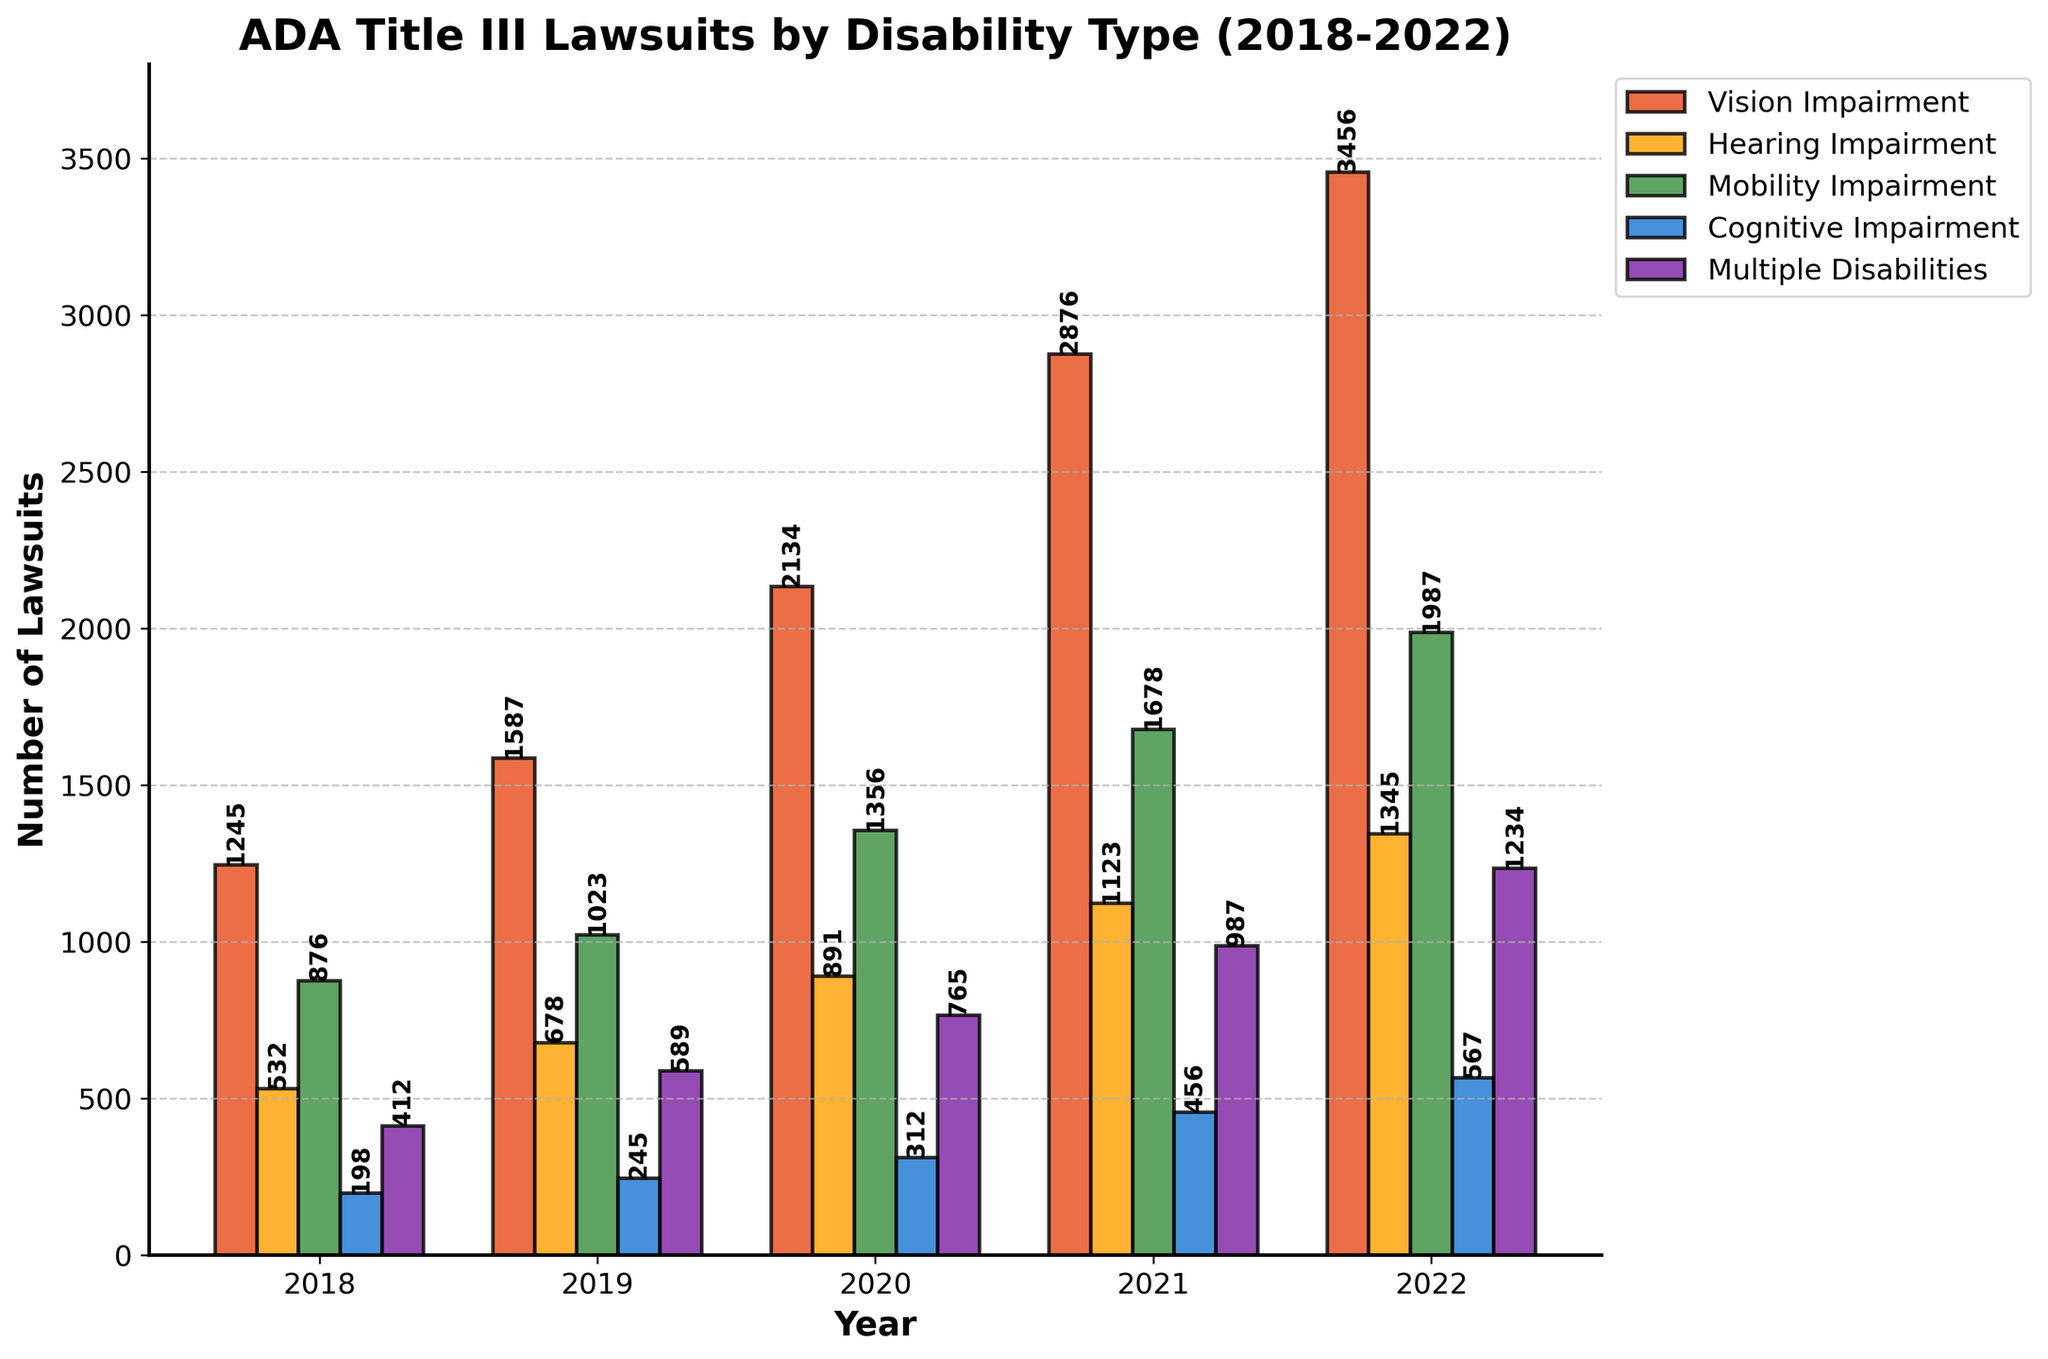What is the total number of lawsuits filed for Vision Impairment over the 5 years? To find the total number of Vision Impairment lawsuits from 2018 to 2022, sum the corresponding values: 1245 + 1587 + 2134 + 2876 + 3456. This gives 11298.
Answer: 11298 Which year had the highest number of lawsuits for Mobility Impairment? By comparing the bar heights representing Mobility Impairment across the years, it is clear that the tallest bar for Mobility Impairment corresponds to the year 2022 with 1987 lawsuits filed.
Answer: 2022 Did the number of Hearing Impairment lawsuits increase every year? Starting from 2018, the numbers for Hearing Impairment are: 532, 678, 891, 1123, and 1345. Comparing each pair sequentially (532 < 678, 678 < 891, 891 < 1123, and 1123 < 1345) confirms that the number of lawsuits increased every year.
Answer: Yes What is the average number of lawsuits filed for Cognitive Impairment from 2018 to 2022? Sum the number of lawsuits for Cognitive Impairment over the 5 years (198 + 245 + 312 + 456 + 567) to get 1778. The average is then 1778 / 5 = 355.6.
Answer: 355.6 Which disability type had the least number of lawsuits filed in 2020? In 2020, the numbers are: Vision Impairment (2134), Hearing Impairment (891), Mobility Impairment (1356), Cognitive Impairment (312), Multiple Disabilities (765). The smallest value is 312 for Cognitive Impairment.
Answer: Cognitive Impairment What is the difference in the number of Mobility Impairment lawsuits between 2018 and 2022? Subtract the number of Mobility Impairment lawsuits in 2018 from that in 2022: 1987 - 876 = 1111.
Answer: 1111 How many more Multiple Disabilities lawsuits were filed in 2021 compared to 2018? Subtract the number of Multiple Disabilities lawsuits in 2018 from that in 2021: 987 - 412 = 575.
Answer: 575 